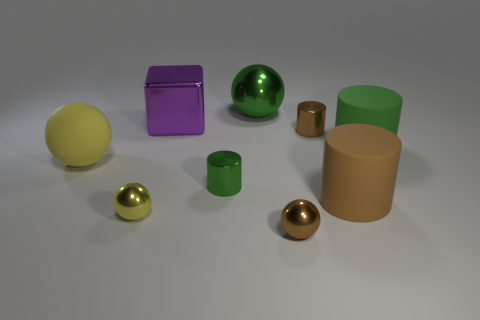Subtract 1 cylinders. How many cylinders are left? 3 Add 1 big yellow matte balls. How many objects exist? 10 Subtract all cylinders. How many objects are left? 5 Add 1 tiny brown shiny spheres. How many tiny brown shiny spheres are left? 2 Add 1 yellow cylinders. How many yellow cylinders exist? 1 Subtract 0 blue cylinders. How many objects are left? 9 Subtract all big purple rubber cylinders. Subtract all large purple shiny objects. How many objects are left? 8 